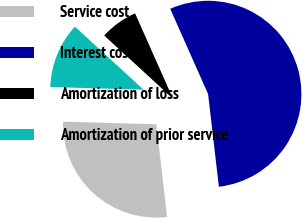Convert chart. <chart><loc_0><loc_0><loc_500><loc_500><pie_chart><fcel>Service cost<fcel>Interest cost<fcel>Amortization of loss<fcel>Amortization of prior service<nl><fcel>27.31%<fcel>54.81%<fcel>6.53%<fcel>11.36%<nl></chart> 